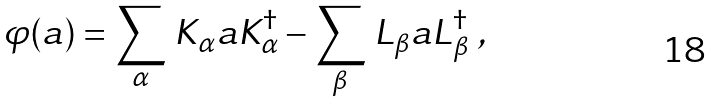<formula> <loc_0><loc_0><loc_500><loc_500>\varphi ( a ) = \sum _ { \alpha } \, K _ { \alpha } a K ^ { \dag } _ { \alpha } - \sum _ { \beta } \, L _ { \beta } a L ^ { \dag } _ { \beta } \ ,</formula> 